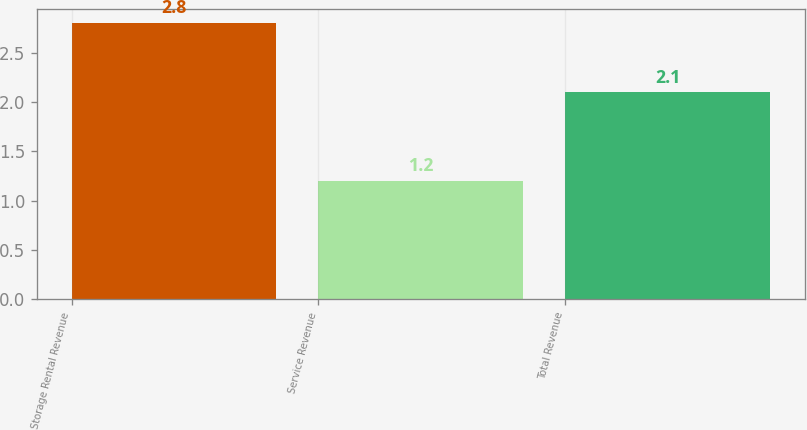Convert chart. <chart><loc_0><loc_0><loc_500><loc_500><bar_chart><fcel>Storage Rental Revenue<fcel>Service Revenue<fcel>Total Revenue<nl><fcel>2.8<fcel>1.2<fcel>2.1<nl></chart> 